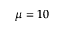<formula> <loc_0><loc_0><loc_500><loc_500>\mu = 1 0</formula> 